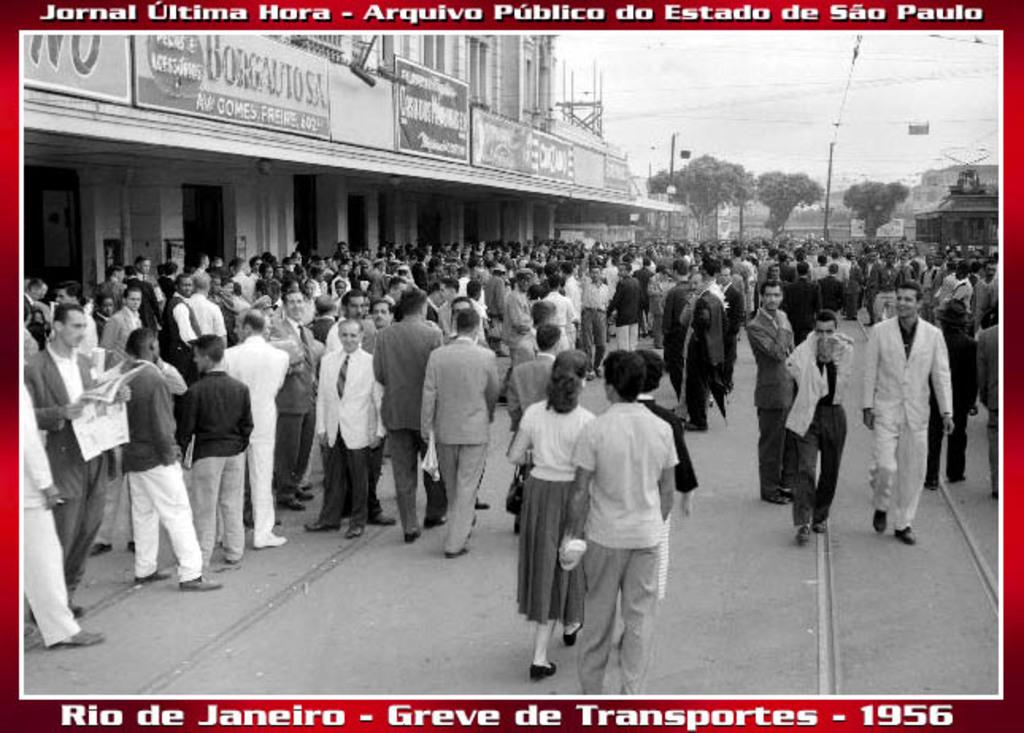What city is this?
Provide a succinct answer. Rio de janeiro. What year was this?
Your response must be concise. 1956. 